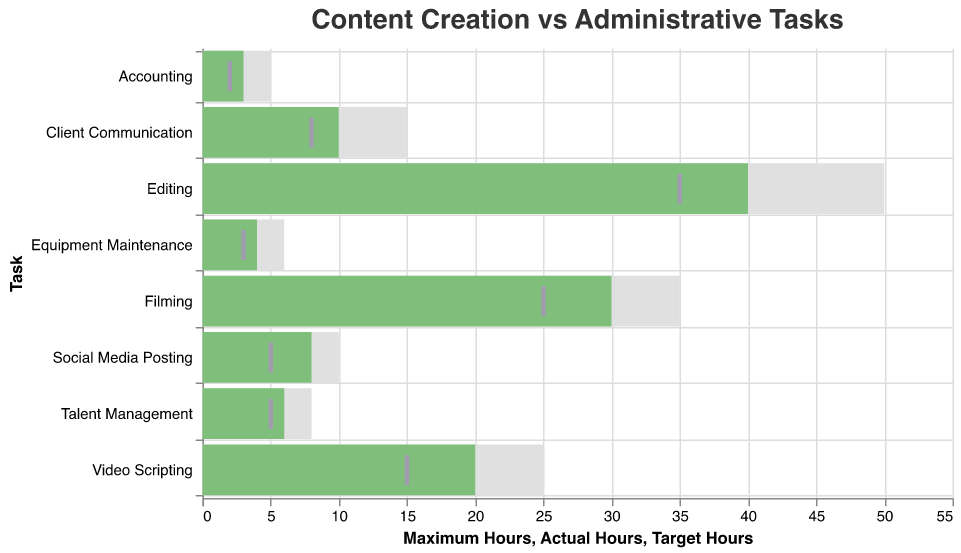What is the title of the chart? The title is located at the top of the chart, and it reads: "Content Creation vs Administrative Tasks"
Answer: Content Creation vs Administrative Tasks Which task takes the most actual hours? By looking at the length of the green bars representing actual hours, editing has the longest bar.
Answer: Editing What is the difference between the actual hours and target hours for video scripting? The actual hours for video scripting are 20, and the target hours are 15. The difference is 20 - 15.
Answer: 5 For which tasks do the actual hours exceed the maximum hours? By comparing the green bars (actual hours) to the gray bars (maximum hours), none of the green bars exceed the gray bars.
Answer: None Which task has the smallest actual hours compared to its maximum hours? By observing which green bar is the shortest relative to its gray bar, accounting has the smallest actual hours (3) compared to its maximum hours (5).
Answer: Accounting What is the total of target hours for all tasks? Summing up all the target hours: 15 (Video Scripting) + 25 (Filming) + 35 (Editing) + 5 (Social Media Posting) + 8 (Client Communication) + 5 (Talent Management) + 3 (Equipment Maintenance) + 2 (Accounting) = 98
Answer: 98 Which task has the largest gap between actual hours and maximum hours? The largest gap is found by calculating the difference for each task: 
Video Scripting: 25 - 20 = 5
Filming: 35 - 30 = 5
Editing: 50 - 40 = 10
Social Media Posting: 10 - 8 = 2
Client Communication: 15 - 10 = 5
Talent Management: 8 - 6 = 2
Equipment Maintenance: 6 - 4 = 2
Accounting: 5 - 3 = 2
Editing has the largest gap.
Answer: Editing How many tasks have a target hour exactly equal to 5? The tasks with target hours precisely 5 are: Social Media Posting and Talent Management.
Answer: 2 Which task has the actual hours closest to its target hours? By checking the proximity between green bars (actual hours) and ticks (target hours), Equipment Maintenance (Actual: 4, Target: 3) has the closest values with a difference of 1 hour.
Answer: Equipment Maintenance 